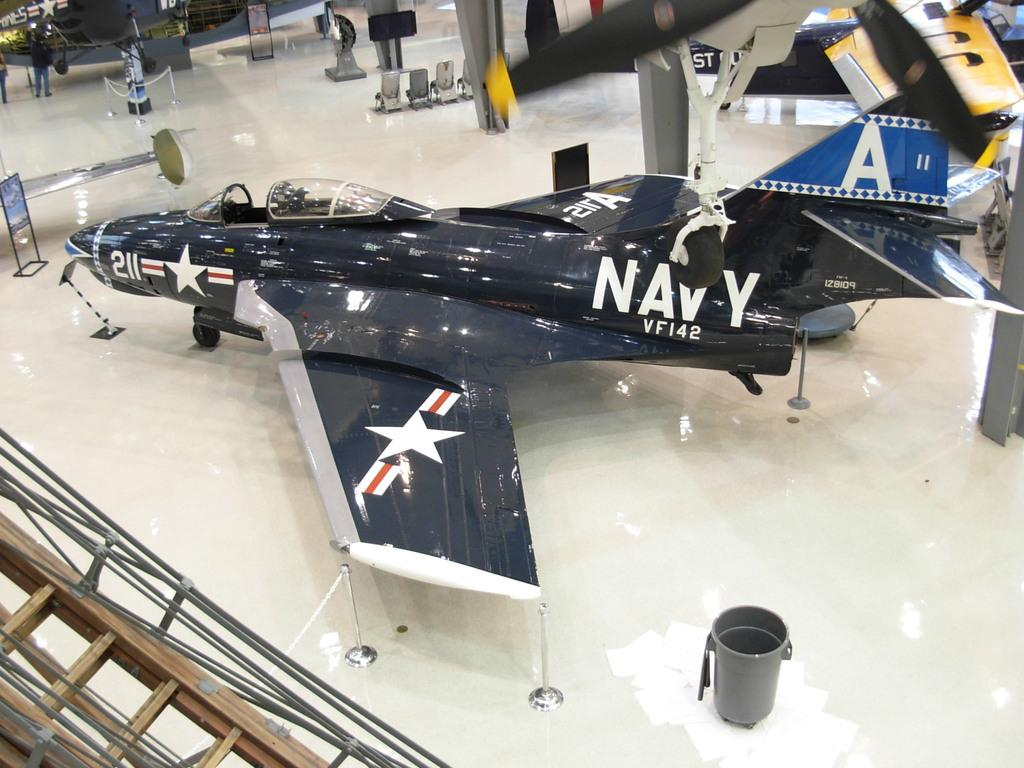<image>
Write a terse but informative summary of the picture. A very shiny Navy jet has the letter A on its tail. 